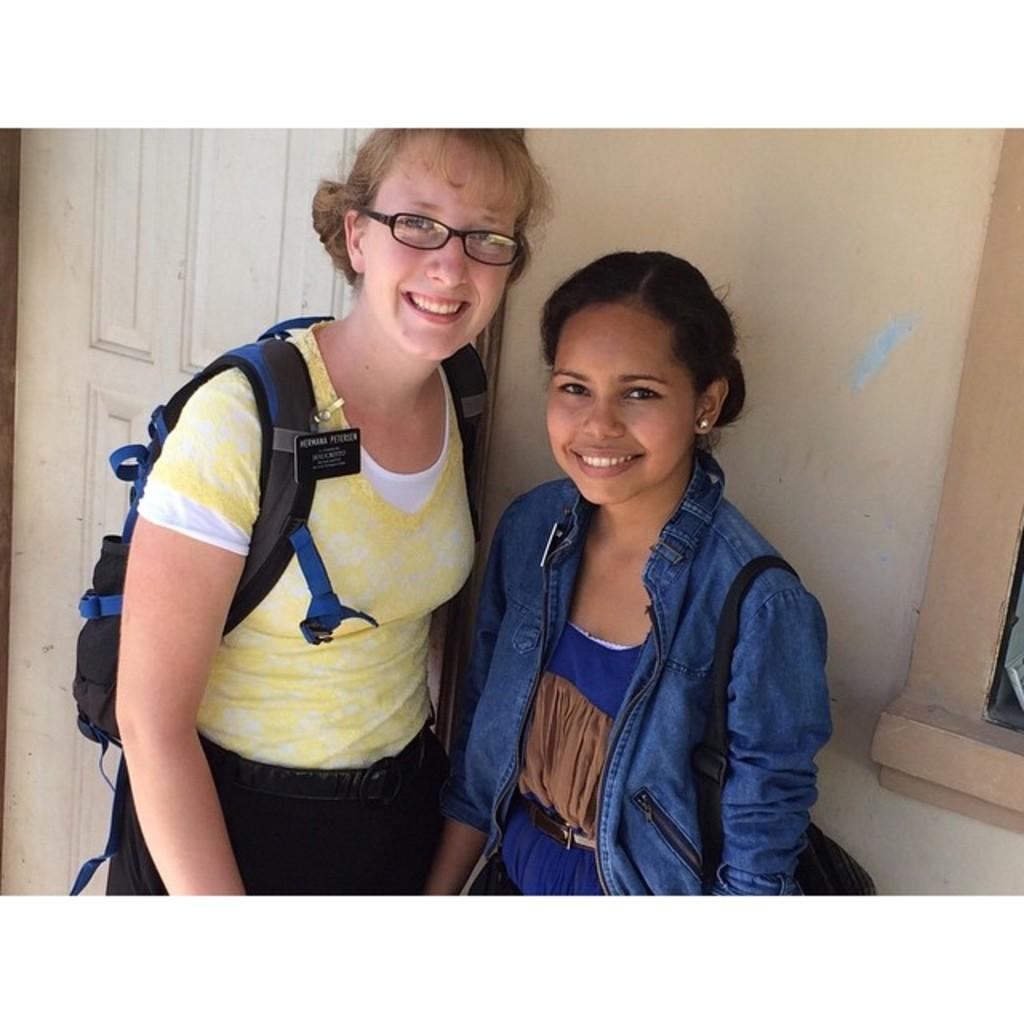How many ladies are present in the image? There are two ladies in the image. What colors are the jackets and shirts worn by the ladies? One lady is wearing a blue color jacket, and the other lady is wearing a yellow color shirt. Do the ladies have any accessories in common? Both ladies have spectacles. What is one lady carrying in the image? One lady is carrying a backpack. What type of air is being discussed by the ladies in the image? There is no indication in the image that the ladies are discussing any type of air. 